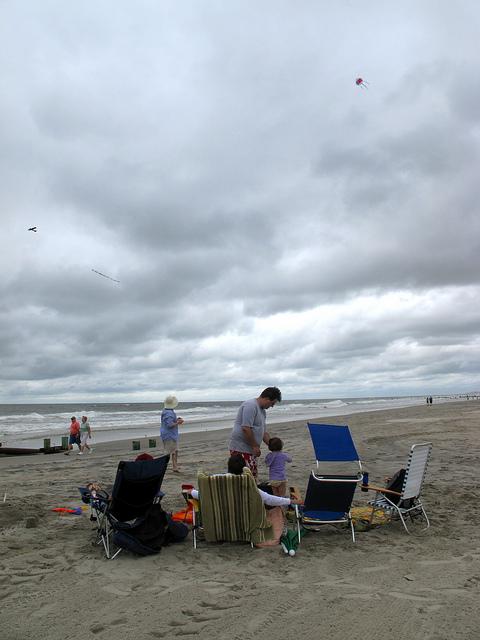Where was this picture taken?
Short answer required. Beach. Could you expect rain?
Answer briefly. Yes. What color shirts are they wearing?
Answer briefly. Gray. What are those objects in the sky?
Keep it brief. Kites. Is this a sunny day?
Give a very brief answer. No. 